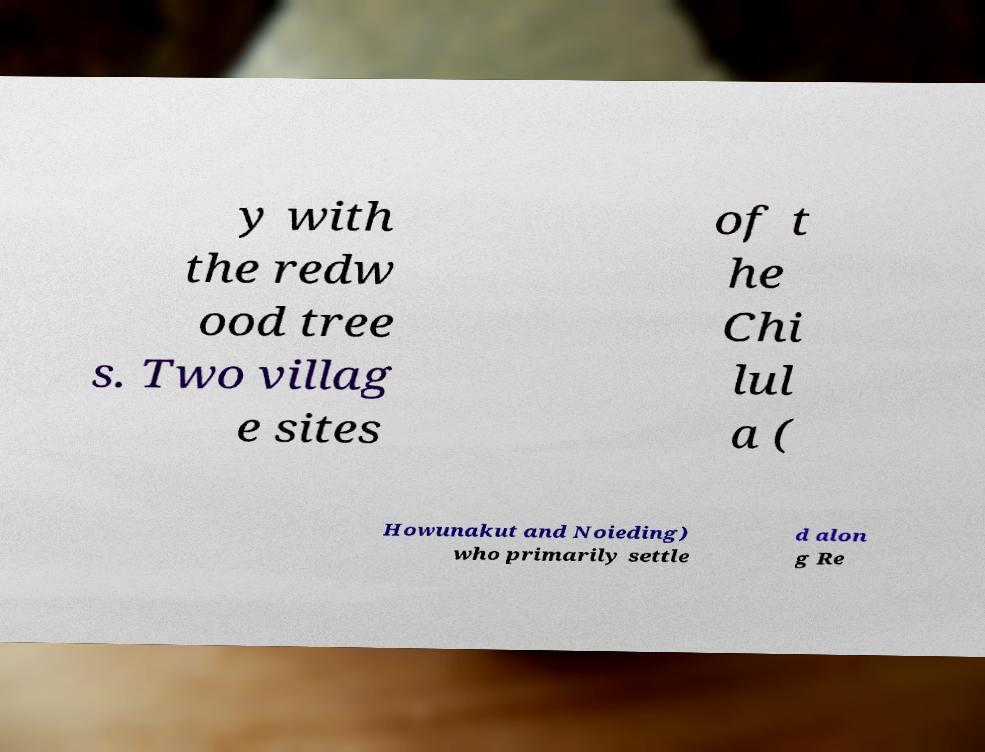Could you extract and type out the text from this image? y with the redw ood tree s. Two villag e sites of t he Chi lul a ( Howunakut and Noieding) who primarily settle d alon g Re 